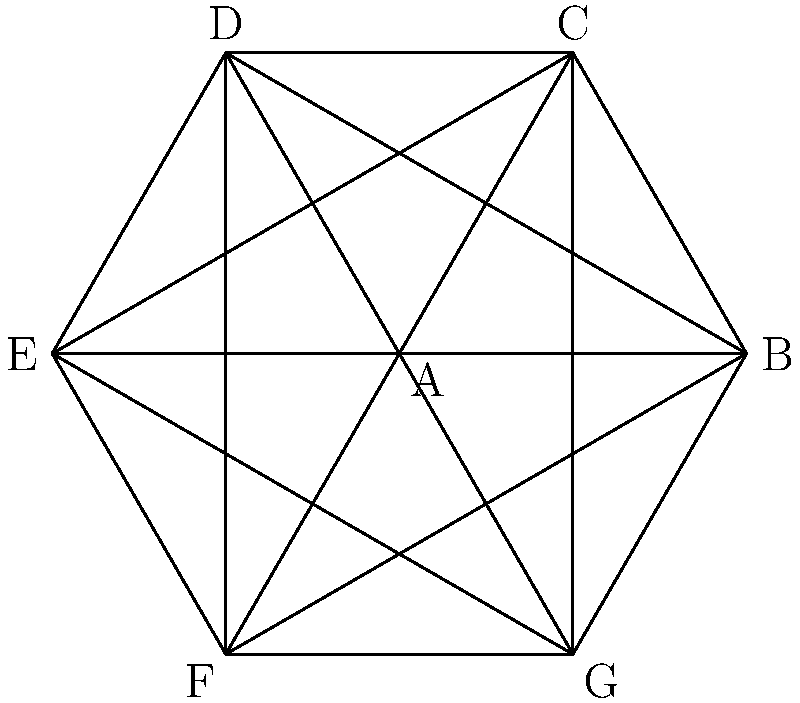In the context of conflicting geopolitical interests, consider the graph above where each vertex represents a country and each edge represents a conflict between two countries. What is the chromatic number of this graph, and how does this relate to the minimum number of distinct geopolitical blocs needed to separate all conflicting parties? To solve this problem, we'll follow these steps:

1. Understand the graph coloring concept:
   - Each color represents a distinct geopolitical bloc.
   - No two adjacent vertices (conflicting countries) can have the same color.

2. Analyze the graph structure:
   - This is a complete graph $K_7$ (every vertex is connected to every other vertex).
   - In a complete graph, every vertex must have a different color.

3. Determine the chromatic number:
   - The chromatic number $\chi(G)$ of a complete graph $K_n$ is always equal to $n$.
   - In this case, $\chi(G) = 7$.

4. Interpret the result:
   - The chromatic number 7 means we need at least 7 distinct colors to properly color the graph.
   - In geopolitical terms, this implies we need at least 7 distinct blocs to separate all conflicting parties.

5. Relate to real-world implications:
   - This high chromatic number suggests a highly complex and divided geopolitical landscape.
   - It indicates that forming stable alliances or negotiating comprehensive peace agreements would be extremely challenging in this scenario.

6. Consider limitations:
   - This model assumes all conflicts are of equal intensity and importance.
   - In reality, some conflicts might be more significant than others, which could affect bloc formation.
Answer: Chromatic number: 7; Minimum geopolitical blocs: 7 